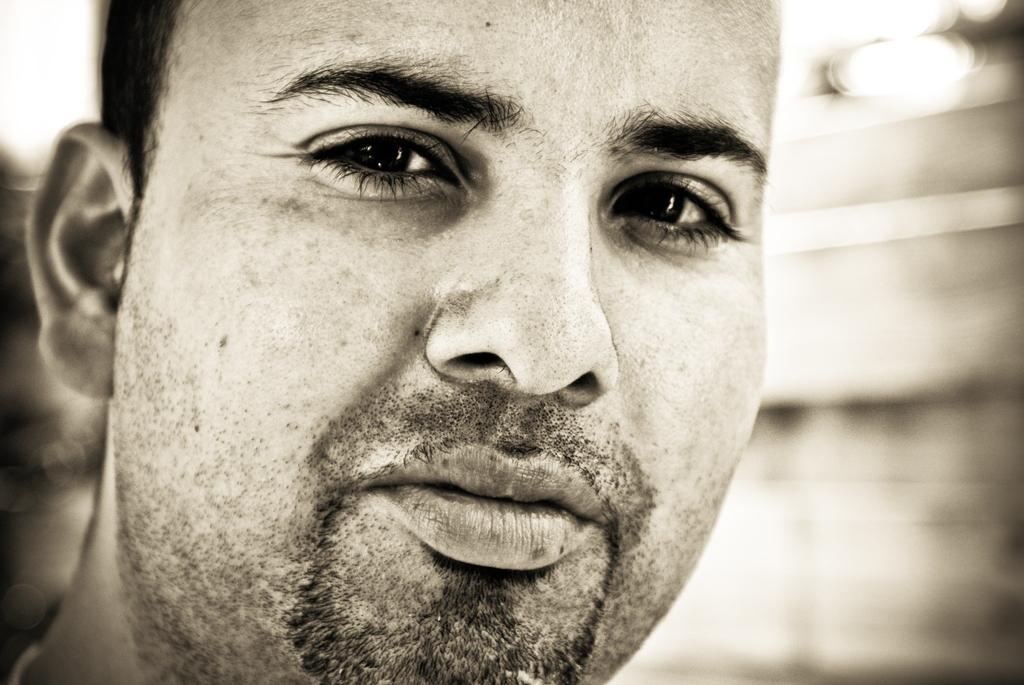What is the main subject of the image? There is a man's face in the image. Can you describe the background of the image? The background of the image is blurry. What type of ring is the man wearing on his finger in the image? There is no ring visible on the man's finger in the image. Can you describe the robin's nest in the image? There is no robin or nest present in the image; it only features a man's face with a blurry background. 